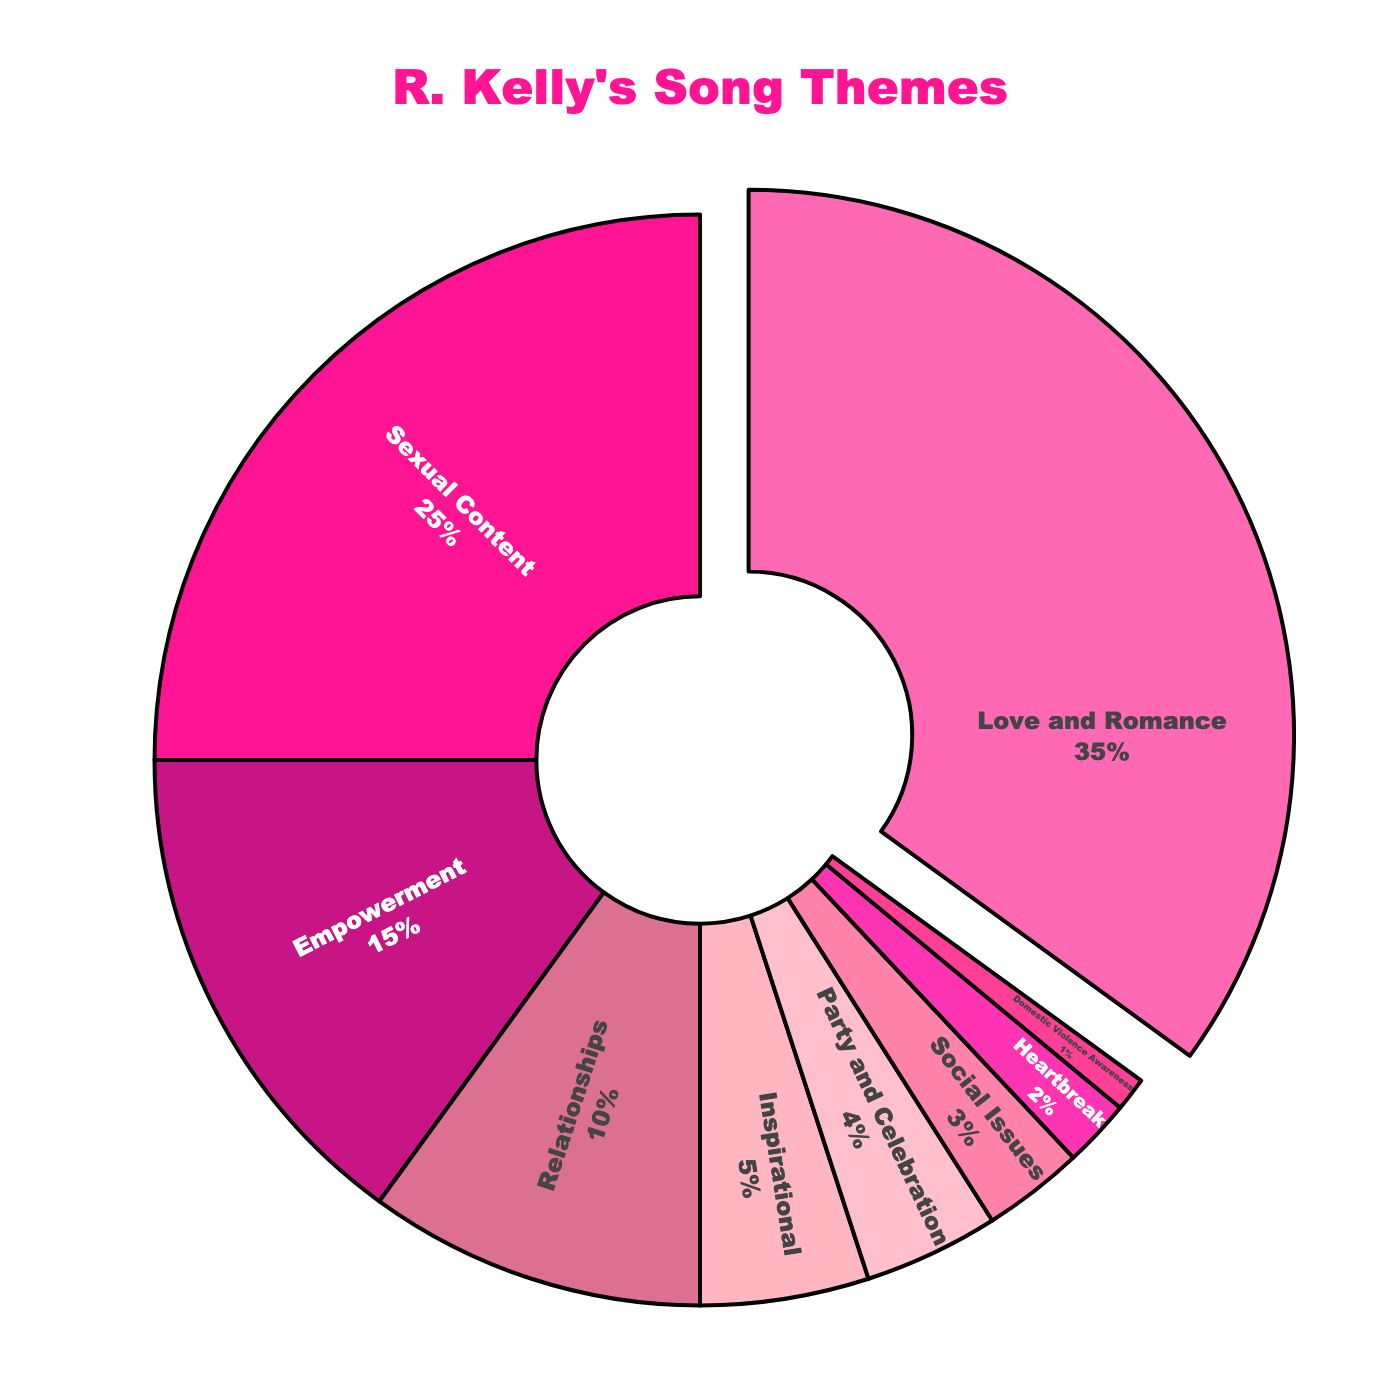what is the percentage of R. Kelly's songs that revolve around love and romance and sexual content combined? To find the combined percentage of songs about love and romance and sexual content, add their individual percentages together: 35% (Love and Romance) + 25% (Sexual Content) = 60%.
Answer: 60% Which lyrical theme has the smallest percentage of R. Kelly's songs? The theme with the smallest percentage is the one with the lowest value in the chart. In this case, it is Domestic Violence Awareness with 1%.
Answer: Domestic Violence Awareness Are there more songs about party and celebration or about social issues? Compare the percentages of songs about party and celebration (4%) and social issues (3%). Party and Celebration has a higher percentage.
Answer: Party and Celebration What is the difference between the percentage of songs about relationships and empowerment? Subtract the percentage of songs about relationships (10%) from the percentage of songs about empowerment (15%): 15% - 10% = 5%.
Answer: 5% Which lyrical theme using pink colors is pulled outwards? The theme that is pulled outwards is the one where the section appears slightly separated from the rest. From the provided data, it's Love and Romance, which is also visually represented using pink colors.
Answer: Love and Romance What percentage of R. Kelly's songs focus on inspirational and empowerment themes together? Add the percentages of songs about inspirational (5%) and empowerment (15%) themes: 5% + 15% = 20%.
Answer: 20% Is the number of songs about heartbreak more, less, or equal to those about domestic violence awareness and social issues combined? Combine the percentages of songs about domestic violence awareness (1%) and social issues (3%): 1% + 3% = 4%. Since songs about heartbreak make up 2%, 2% is less than 4%.
Answer: Less What percentage of R. Kelly’s songs are not about love and romance? Subtract the percentage of songs about love and romance (35%) from 100%: 100% - 35% = 65%.
Answer: 65% Which two themes combined make up exactly 9% of R. Kelly's songs? Look for two themes that sum to 9%. In this case, Party and Celebration (4%) and Heartbreak (2%) combined with Domestic Violence Awareness (1%) equals 7%, but Relationships (10%) can't be further decomposed. There are no two themes that make up exactly 9%. However, Social Issues (3%) and Party and Celebration (4%) sum up to 7%. None other matches.
Answer: None Which themes have a percentage below 5%? Identify themes with percentages less than 5%: Party and Celebration (4%), Social Issues (3%), Heartbreak (2%), Domestic Violence Awareness (1%).
Answer: Party and Celebration, Social Issues, Heartbreak, Domestic Violence Awareness 